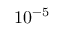Convert formula to latex. <formula><loc_0><loc_0><loc_500><loc_500>1 0 ^ { - 5 }</formula> 